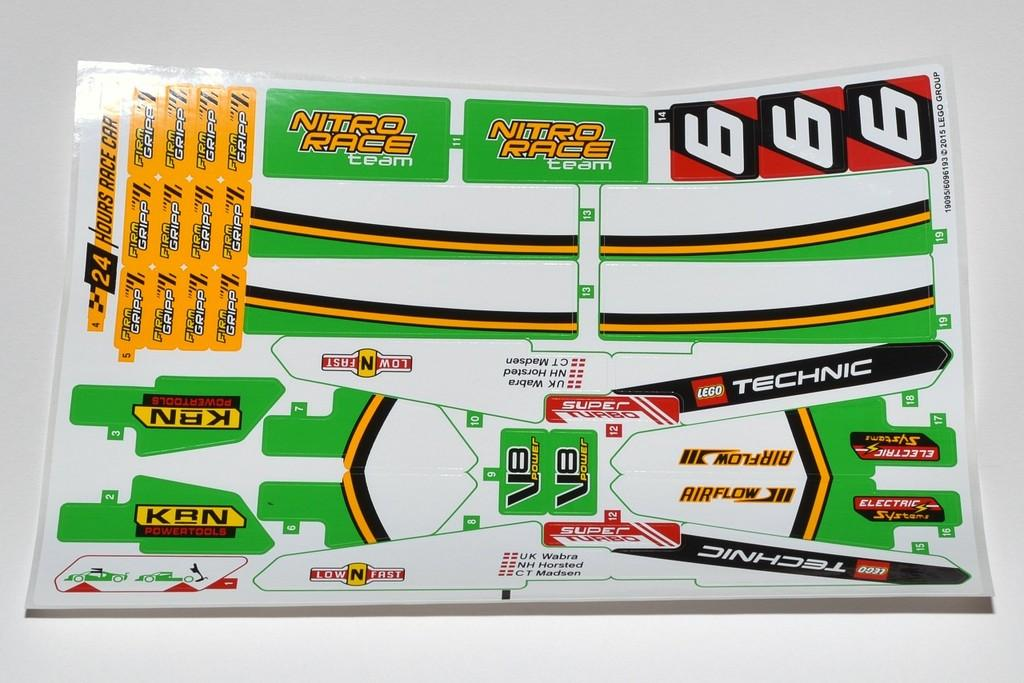<image>
Share a concise interpretation of the image provided. A sticker kit for a Lego Technic including three number 6 stickers. 